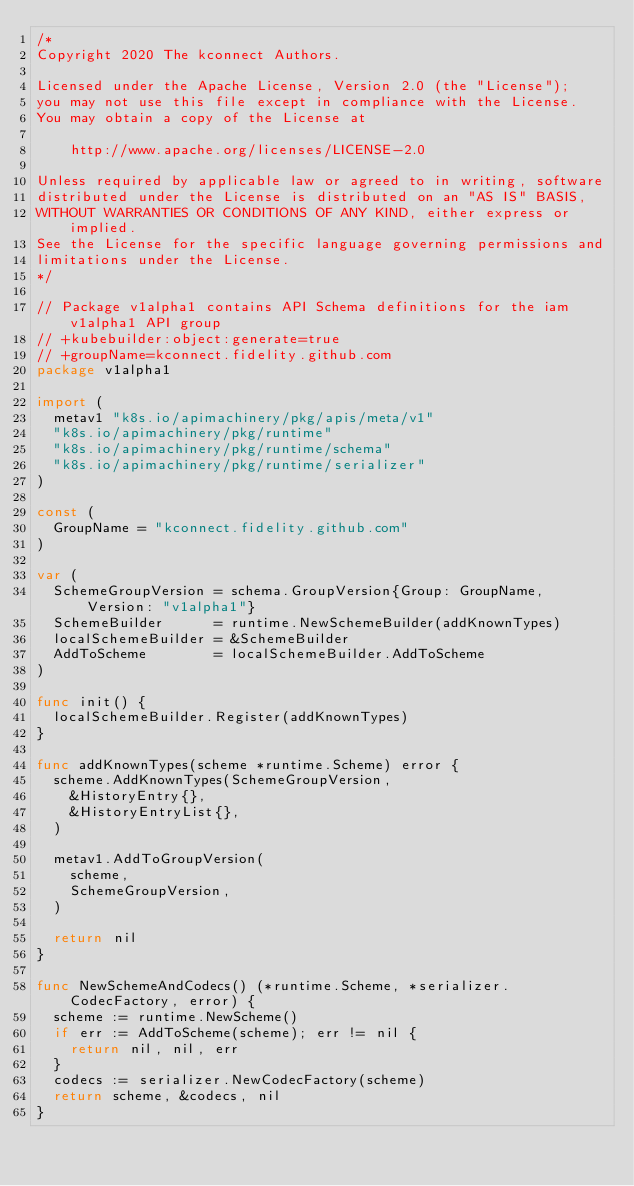Convert code to text. <code><loc_0><loc_0><loc_500><loc_500><_Go_>/*
Copyright 2020 The kconnect Authors.

Licensed under the Apache License, Version 2.0 (the "License");
you may not use this file except in compliance with the License.
You may obtain a copy of the License at

    http://www.apache.org/licenses/LICENSE-2.0

Unless required by applicable law or agreed to in writing, software
distributed under the License is distributed on an "AS IS" BASIS,
WITHOUT WARRANTIES OR CONDITIONS OF ANY KIND, either express or implied.
See the License for the specific language governing permissions and
limitations under the License.
*/

// Package v1alpha1 contains API Schema definitions for the iam v1alpha1 API group
// +kubebuilder:object:generate=true
// +groupName=kconnect.fidelity.github.com
package v1alpha1

import (
	metav1 "k8s.io/apimachinery/pkg/apis/meta/v1"
	"k8s.io/apimachinery/pkg/runtime"
	"k8s.io/apimachinery/pkg/runtime/schema"
	"k8s.io/apimachinery/pkg/runtime/serializer"
)

const (
	GroupName = "kconnect.fidelity.github.com"
)

var (
	SchemeGroupVersion = schema.GroupVersion{Group: GroupName, Version: "v1alpha1"}
	SchemeBuilder      = runtime.NewSchemeBuilder(addKnownTypes)
	localSchemeBuilder = &SchemeBuilder
	AddToScheme        = localSchemeBuilder.AddToScheme
)

func init() {
	localSchemeBuilder.Register(addKnownTypes)
}

func addKnownTypes(scheme *runtime.Scheme) error {
	scheme.AddKnownTypes(SchemeGroupVersion,
		&HistoryEntry{},
		&HistoryEntryList{},
	)

	metav1.AddToGroupVersion(
		scheme,
		SchemeGroupVersion,
	)

	return nil
}

func NewSchemeAndCodecs() (*runtime.Scheme, *serializer.CodecFactory, error) {
	scheme := runtime.NewScheme()
	if err := AddToScheme(scheme); err != nil {
		return nil, nil, err
	}
	codecs := serializer.NewCodecFactory(scheme)
	return scheme, &codecs, nil
}
</code> 